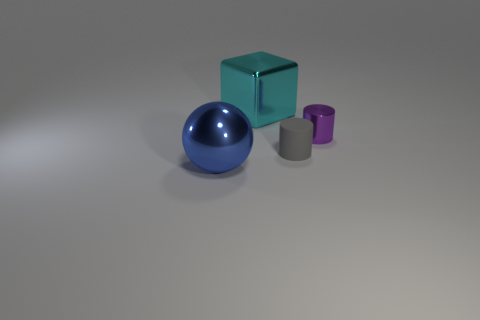Add 3 gray things. How many objects exist? 7 Subtract all blocks. How many objects are left? 3 Add 4 small metallic cylinders. How many small metallic cylinders are left? 5 Add 3 large cyan cubes. How many large cyan cubes exist? 4 Subtract 0 red spheres. How many objects are left? 4 Subtract all purple metal blocks. Subtract all small purple things. How many objects are left? 3 